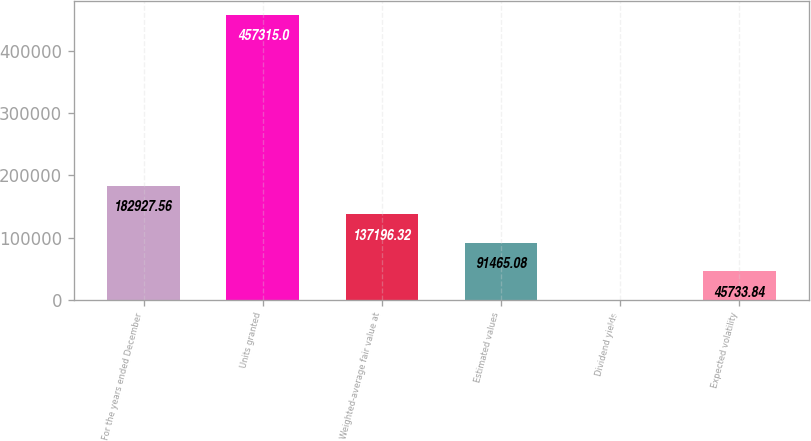Convert chart. <chart><loc_0><loc_0><loc_500><loc_500><bar_chart><fcel>For the years ended December<fcel>Units granted<fcel>Weighted-average fair value at<fcel>Estimated values<fcel>Dividend yields<fcel>Expected volatility<nl><fcel>182928<fcel>457315<fcel>137196<fcel>91465.1<fcel>2.6<fcel>45733.8<nl></chart> 